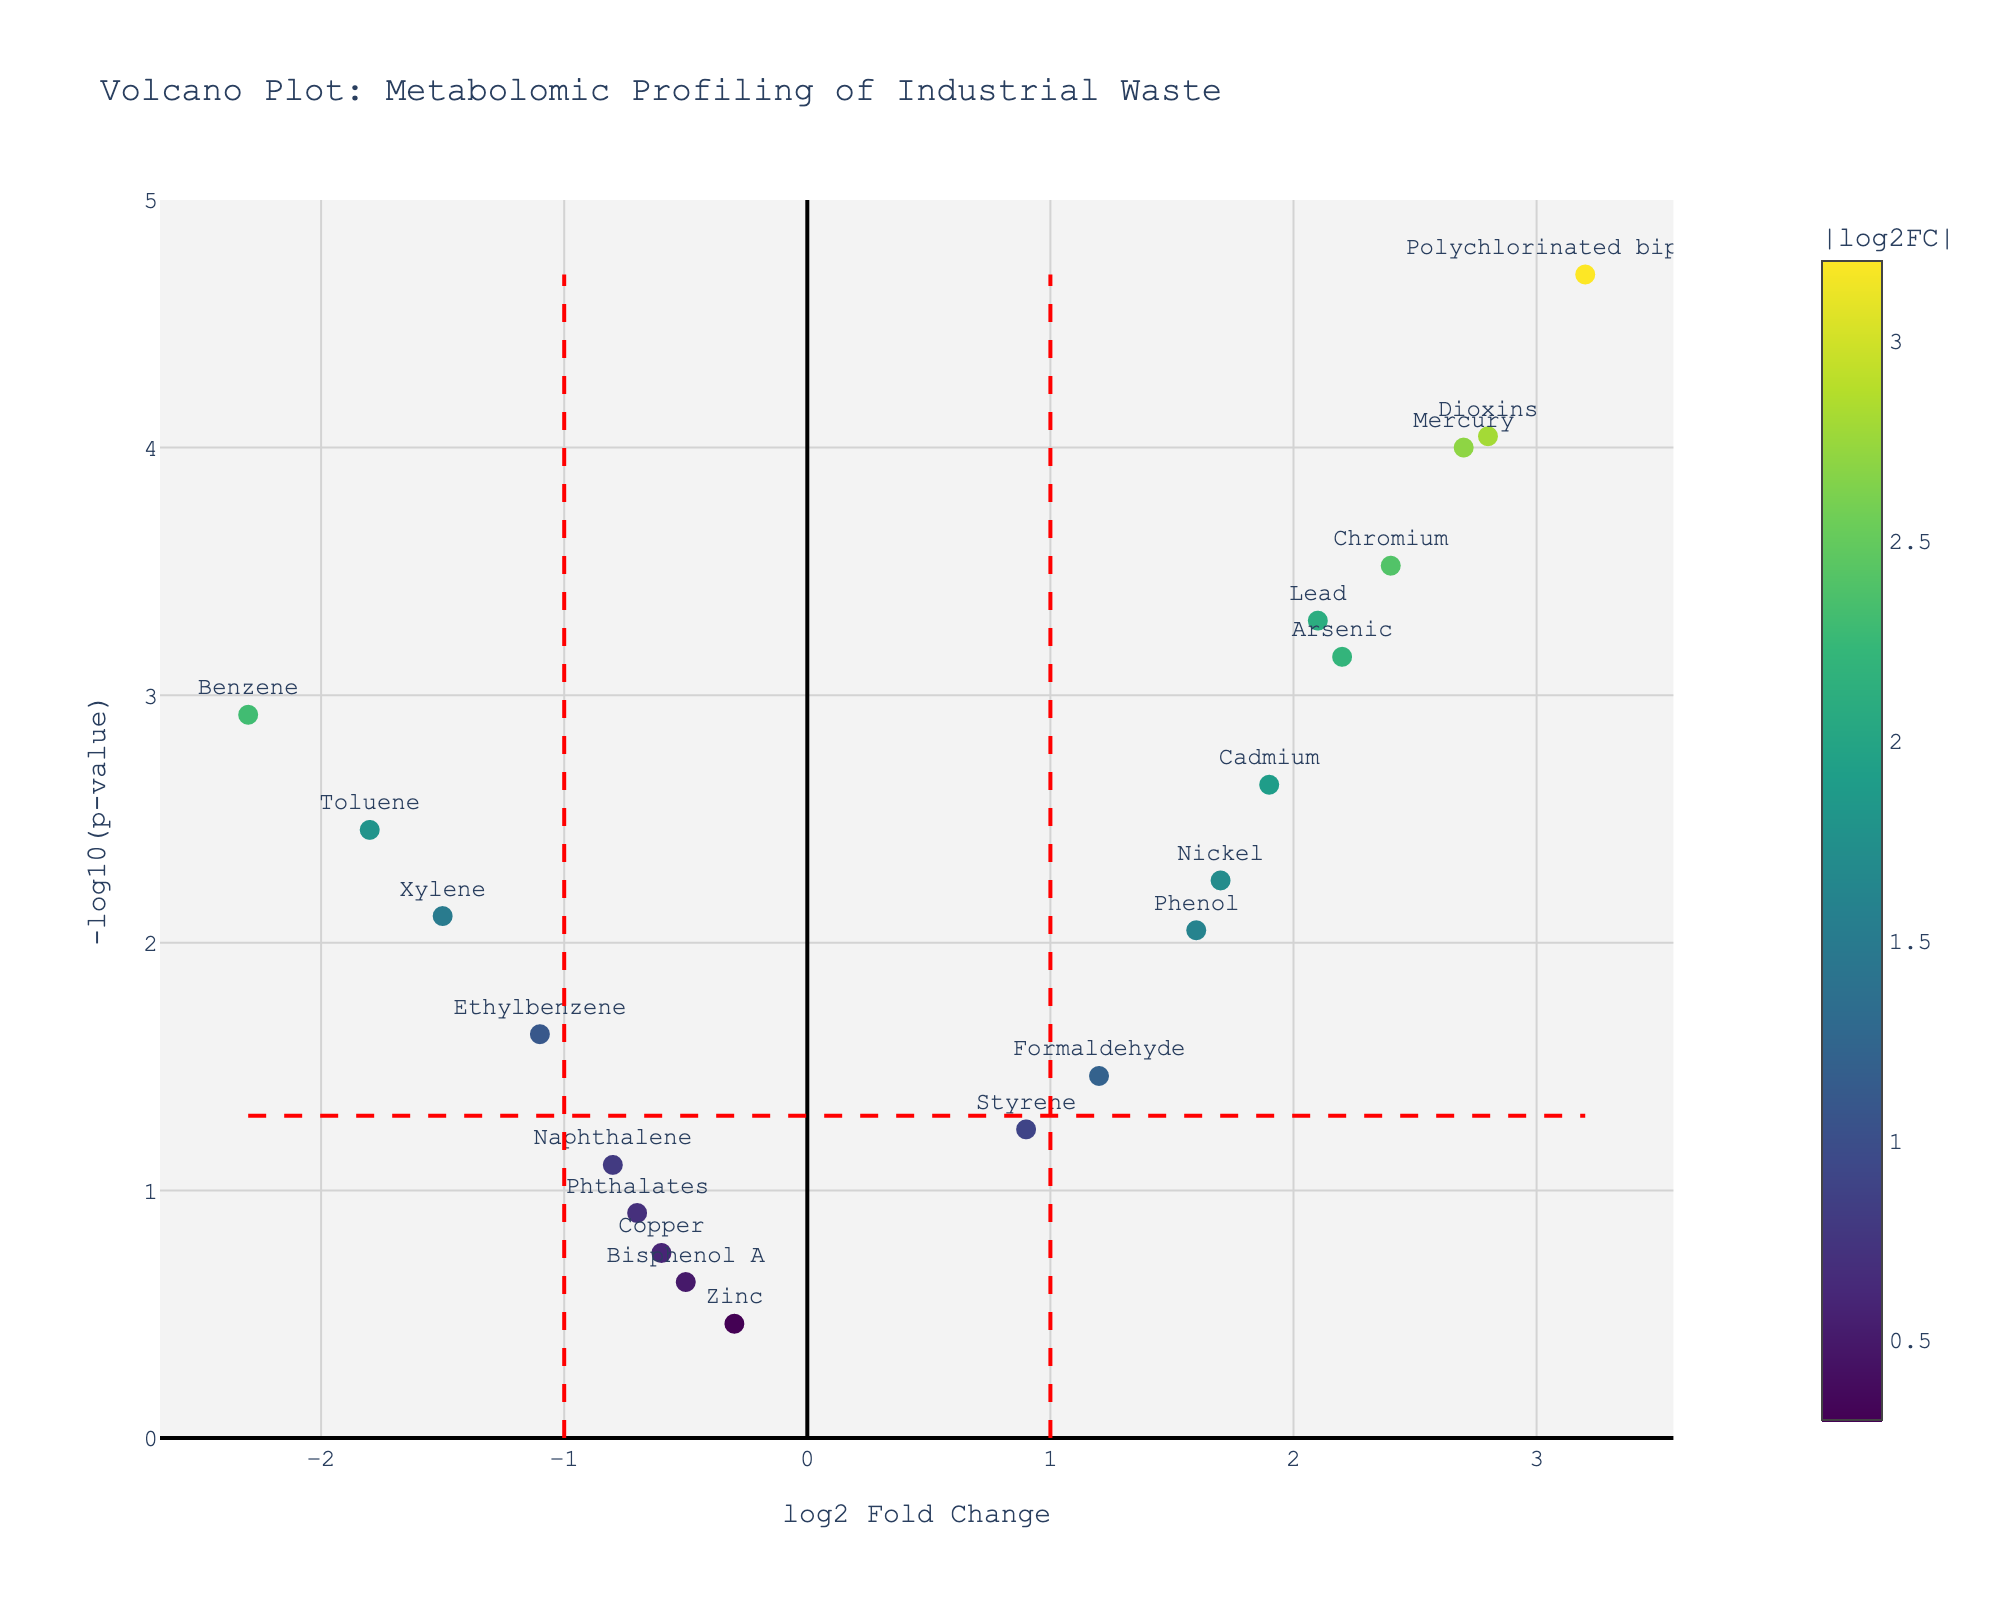what is the title of the plot? The title is typically placed at the top of the figure. In this case, it reads "Volcano Plot: Metabolomic Profiling of Industrial Waste."
Answer: Volcano Plot: Metabolomic Profiling of Industrial Waste What are the axis labels on the plot? The x-axis label reads "log2 Fold Change," and the y-axis label reads "-log10(p-value)." These labels are placed alongside each respective axis.
Answer: log2 Fold Change and -log10(p-value) How many data points are below the p-value threshold line? The p-value threshold line is represented by the horizontal red dashed line. Data points below this line are less statistically significant; hence, points above the line are counted. There are 14 data points above this line.
Answer: 14 Which compound has the highest fold change? Look for the data point most right on the x-axis, which represents the log2 fold change. The compound "Polychlorinated biphenyls" is furthest to the right, indicating the highest fold change.
Answer: Polychlorinated biphenyls Which compound has the lowest p-value? The p-value is inversely related to the y-axis value "-log10(p-value)." The compound highest on the y-axis, "Polychlorinated biphenyls," has the lowest p-value.
Answer: Polychlorinated biphenyls How many compounds have an absolute log2 fold change greater than 1? The absolute log2 fold change greater than 1 means compounds on either side of the vertical red dashed lines. Count the data points outside these lines: Benzene, Toluene, Xylene, Lead, Mercury, Cadmium, Polychlorinated biphenyls, Dioxins, Formaldehyde, Phenol, Chromium, Nickel, Arsenic.
Answer: 13 Which compounds fall into the "significantly upregulated" category (log2FC > 1 and p-value < 0.05)? Look for data points located to the right of the vertical red dashed line (log2 Fold Change > 1) and above the horizontal red dashed line (p-value < 0.05): Lead, Mercury, Cadmium, Polychlorinated biphenyls, Dioxins, Phenol, Chromium, Nickel, Arsenic.
Answer: 9 Compare the log2 fold change of Lead and Mercury. Which has the higher value? Locate both compounds on the plot. Lead's log2 Fold Change is 2.1, and Mercury's is 2.7. Mercury has a higher fold change.
Answer: Mercury What is the combined log2 fold change of Toluene and Xylene? The log2 fold change for Toluene is -1.8, and for Xylene, it is -1.5. Adding these values together gives -1.8 + (-1.5) = -3.3.
Answer: -3.3 